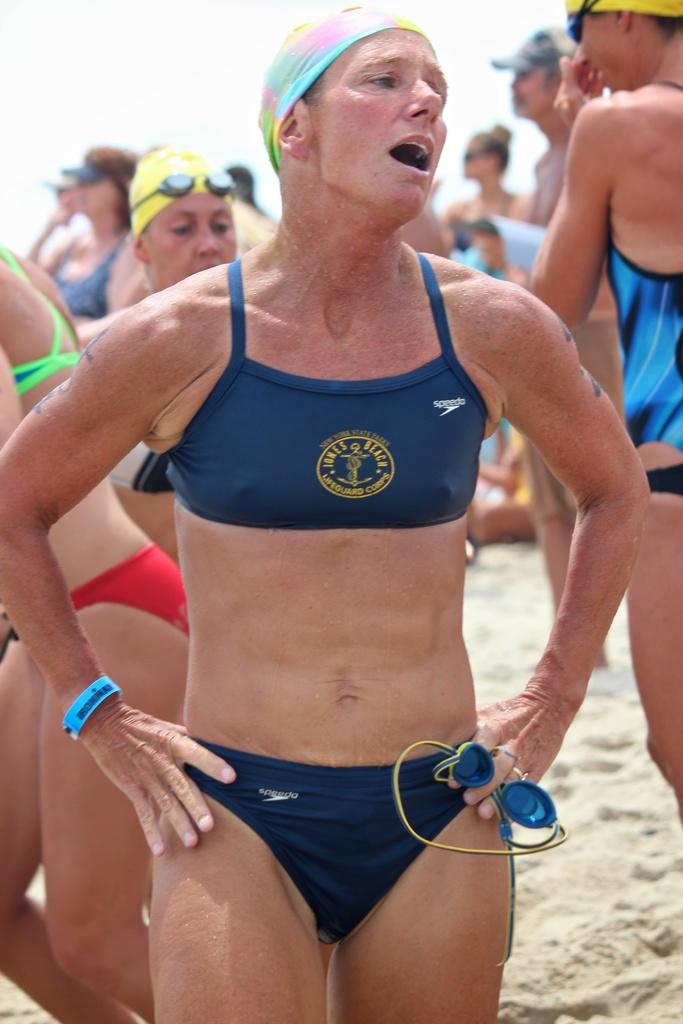Who is present in the picture? There are women in the picture. What are the women wearing? The women are wearing swimsuits. What type of surface are the women standing on? The women are standing on sand. What is the size of the mailbox near the women in the picture? There is no mailbox present in the image. How long is the journey the women are about to embark on? The image does not provide any information about a journey the women are about to embark on. 